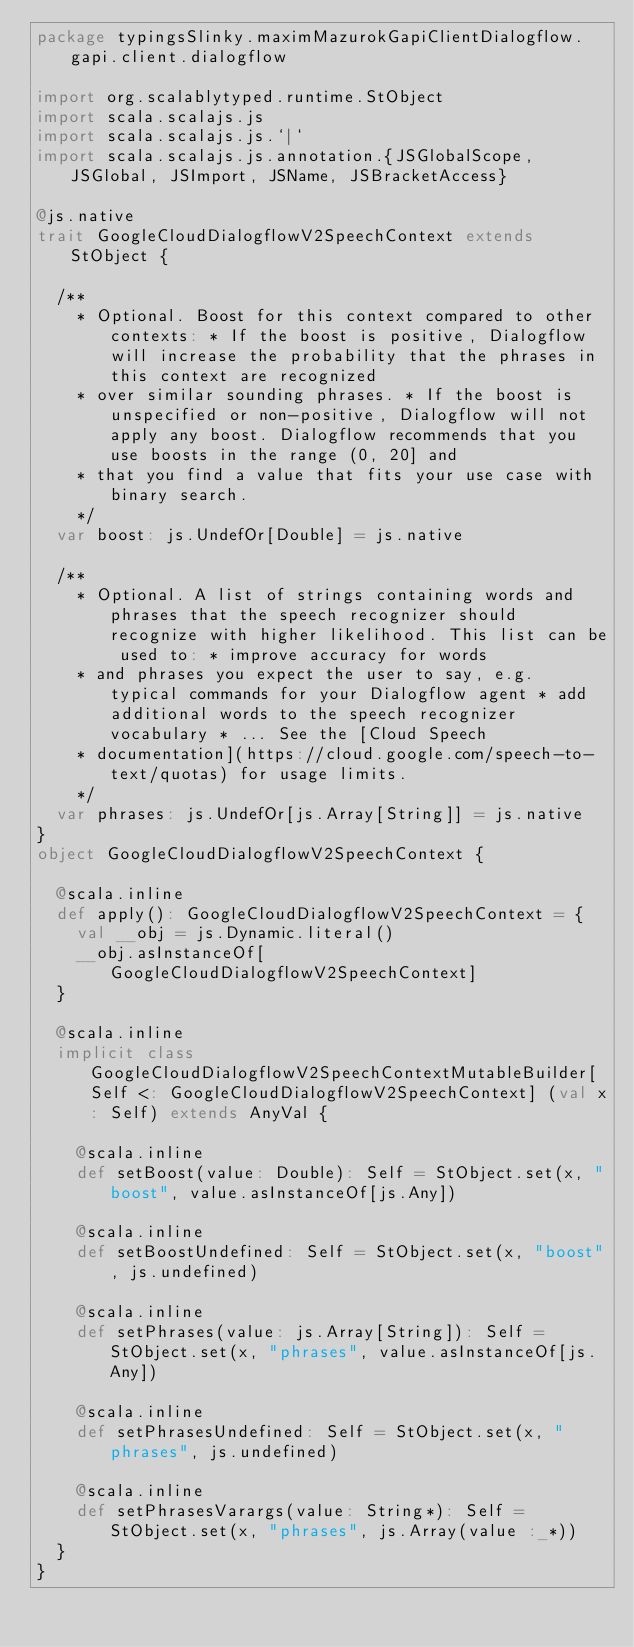<code> <loc_0><loc_0><loc_500><loc_500><_Scala_>package typingsSlinky.maximMazurokGapiClientDialogflow.gapi.client.dialogflow

import org.scalablytyped.runtime.StObject
import scala.scalajs.js
import scala.scalajs.js.`|`
import scala.scalajs.js.annotation.{JSGlobalScope, JSGlobal, JSImport, JSName, JSBracketAccess}

@js.native
trait GoogleCloudDialogflowV2SpeechContext extends StObject {
  
  /**
    * Optional. Boost for this context compared to other contexts: * If the boost is positive, Dialogflow will increase the probability that the phrases in this context are recognized
    * over similar sounding phrases. * If the boost is unspecified or non-positive, Dialogflow will not apply any boost. Dialogflow recommends that you use boosts in the range (0, 20] and
    * that you find a value that fits your use case with binary search.
    */
  var boost: js.UndefOr[Double] = js.native
  
  /**
    * Optional. A list of strings containing words and phrases that the speech recognizer should recognize with higher likelihood. This list can be used to: * improve accuracy for words
    * and phrases you expect the user to say, e.g. typical commands for your Dialogflow agent * add additional words to the speech recognizer vocabulary * ... See the [Cloud Speech
    * documentation](https://cloud.google.com/speech-to-text/quotas) for usage limits.
    */
  var phrases: js.UndefOr[js.Array[String]] = js.native
}
object GoogleCloudDialogflowV2SpeechContext {
  
  @scala.inline
  def apply(): GoogleCloudDialogflowV2SpeechContext = {
    val __obj = js.Dynamic.literal()
    __obj.asInstanceOf[GoogleCloudDialogflowV2SpeechContext]
  }
  
  @scala.inline
  implicit class GoogleCloudDialogflowV2SpeechContextMutableBuilder[Self <: GoogleCloudDialogflowV2SpeechContext] (val x: Self) extends AnyVal {
    
    @scala.inline
    def setBoost(value: Double): Self = StObject.set(x, "boost", value.asInstanceOf[js.Any])
    
    @scala.inline
    def setBoostUndefined: Self = StObject.set(x, "boost", js.undefined)
    
    @scala.inline
    def setPhrases(value: js.Array[String]): Self = StObject.set(x, "phrases", value.asInstanceOf[js.Any])
    
    @scala.inline
    def setPhrasesUndefined: Self = StObject.set(x, "phrases", js.undefined)
    
    @scala.inline
    def setPhrasesVarargs(value: String*): Self = StObject.set(x, "phrases", js.Array(value :_*))
  }
}
</code> 